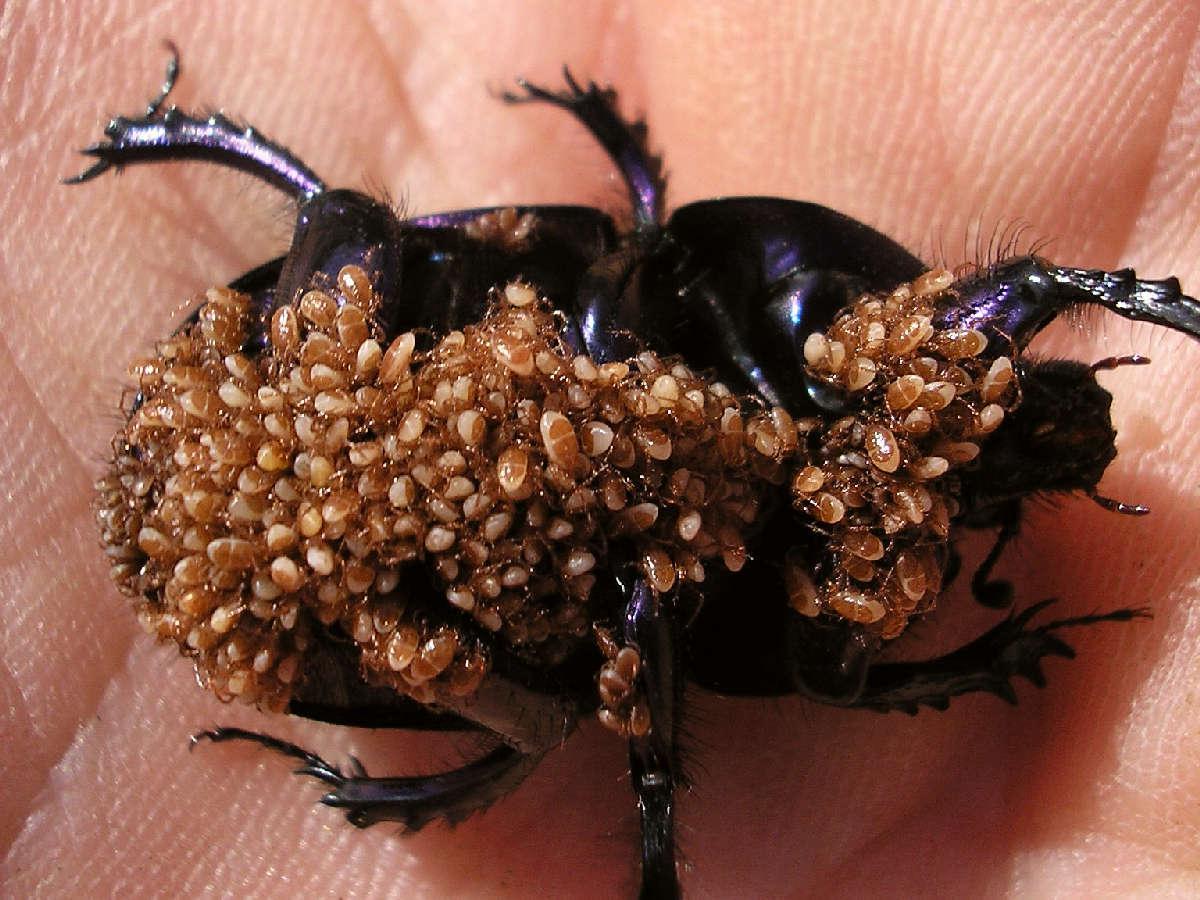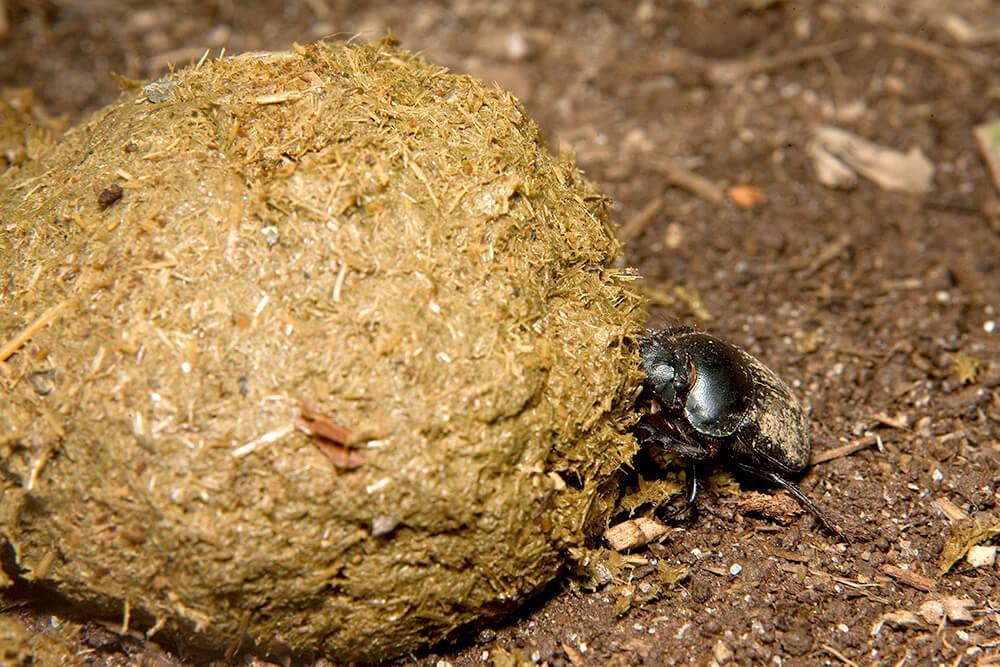The first image is the image on the left, the second image is the image on the right. Considering the images on both sides, is "Each image contains a single rounded dung ball, and at least one image contains two beetles." valid? Answer yes or no. No. The first image is the image on the left, the second image is the image on the right. Evaluate the accuracy of this statement regarding the images: "One image displays two beetles on the same dung ball.". Is it true? Answer yes or no. No. 